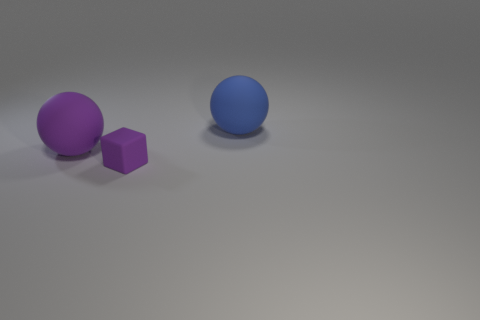Is there anything else that has the same size as the purple matte cube?
Your answer should be very brief. No. What number of other things are the same shape as the blue rubber object?
Provide a succinct answer. 1. Are there more small rubber things that are on the right side of the large blue sphere than big things?
Provide a succinct answer. No. The other object that is the same shape as the blue thing is what size?
Provide a short and direct response. Large. Is there any other thing that is the same material as the cube?
Make the answer very short. Yes. What shape is the small thing?
Keep it short and to the point. Cube. Is there anything else of the same color as the tiny rubber block?
Give a very brief answer. Yes. What size is the blue sphere that is made of the same material as the purple cube?
Your answer should be very brief. Large. There is a large blue thing; is it the same shape as the purple thing that is to the right of the purple matte sphere?
Offer a terse response. No. The purple sphere is what size?
Make the answer very short. Large. 